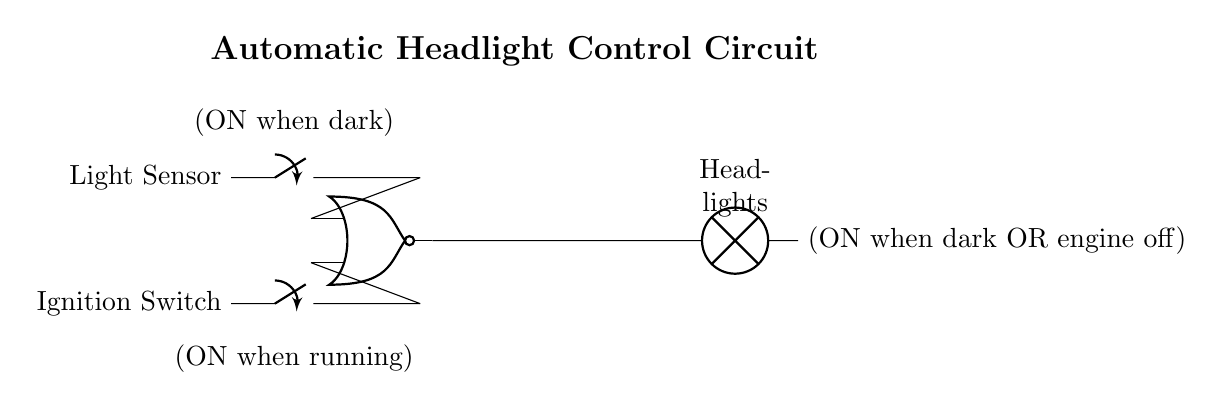What type of gate is used in this circuit? The circuit uses a NOR gate, as indicated by the label on the gate itself.
Answer: NOR gate How many inputs does the NOR gate have? The NOR gate in this circuit has two inputs, which are connected to the light sensor and the ignition switch.
Answer: Two What condition will turn the headlights ON? The headlights will turn ON when it is dark (light sensor inactive) or when the ignition switch is off, as expressed by the NOR operation in the circuit.
Answer: When dark or engine off What is the function of the light sensor? The light sensor's function is to detect ambient light levels and control the state of the NOR gate based on whether it is dark or not.
Answer: Detects ambient light What happens if the ignition switch is ON and it is bright? If the ignition switch is ON and it is bright, the light sensor will signal the NOR gate to keep the headlights OFF.
Answer: Headlights OFF What does the output indicate when both inputs are high? When both inputs (light sensor and ignition switch) are high, the output of the NOR gate will be low, meaning the headlights will remain OFF.
Answer: Headlights OFF 